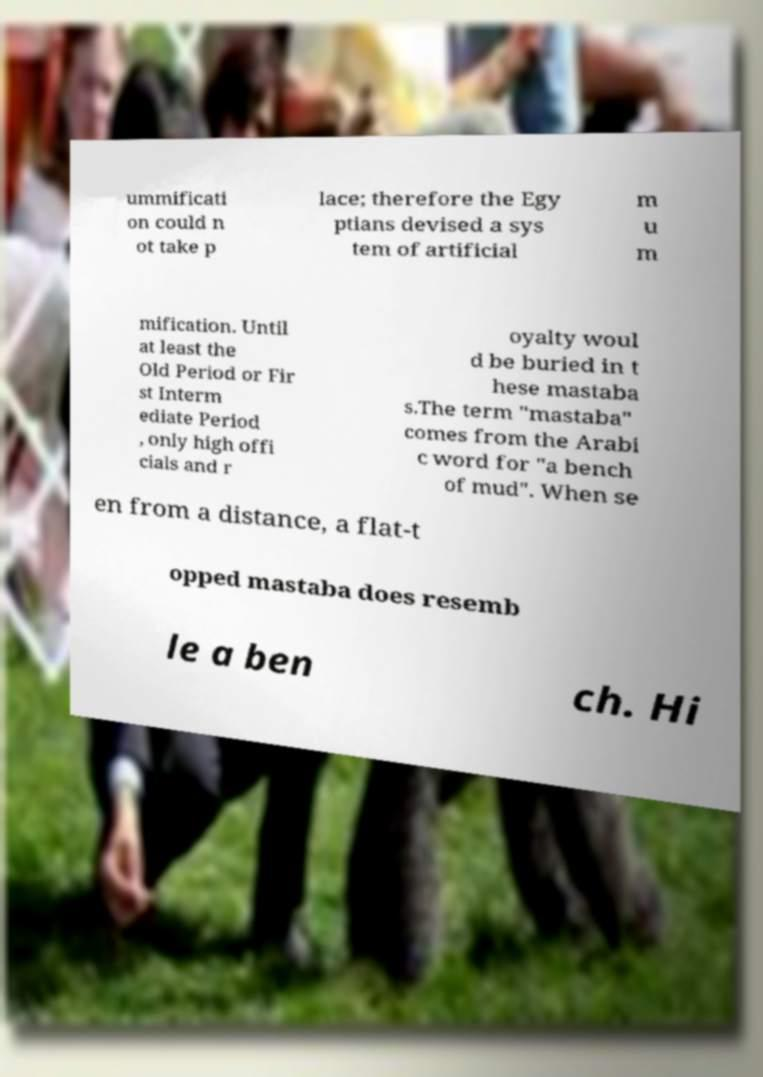For documentation purposes, I need the text within this image transcribed. Could you provide that? ummificati on could n ot take p lace; therefore the Egy ptians devised a sys tem of artificial m u m mification. Until at least the Old Period or Fir st Interm ediate Period , only high offi cials and r oyalty woul d be buried in t hese mastaba s.The term "mastaba" comes from the Arabi c word for "a bench of mud". When se en from a distance, a flat-t opped mastaba does resemb le a ben ch. Hi 